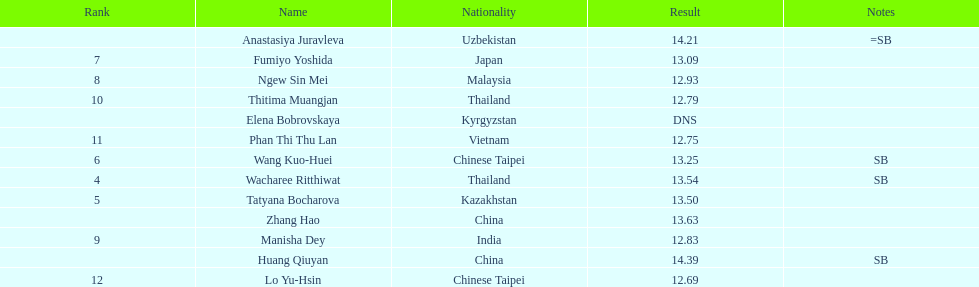Give me the full table as a dictionary. {'header': ['Rank', 'Name', 'Nationality', 'Result', 'Notes'], 'rows': [['', 'Anastasiya Juravleva', 'Uzbekistan', '14.21', '=SB'], ['7', 'Fumiyo Yoshida', 'Japan', '13.09', ''], ['8', 'Ngew Sin Mei', 'Malaysia', '12.93', ''], ['10', 'Thitima Muangjan', 'Thailand', '12.79', ''], ['', 'Elena Bobrovskaya', 'Kyrgyzstan', 'DNS', ''], ['11', 'Phan Thi Thu Lan', 'Vietnam', '12.75', ''], ['6', 'Wang Kuo-Huei', 'Chinese Taipei', '13.25', 'SB'], ['4', 'Wacharee Ritthiwat', 'Thailand', '13.54', 'SB'], ['5', 'Tatyana Bocharova', 'Kazakhstan', '13.50', ''], ['', 'Zhang Hao', 'China', '13.63', ''], ['9', 'Manisha Dey', 'India', '12.83', ''], ['', 'Huang Qiuyan', 'China', '14.39', 'SB'], ['12', 'Lo Yu-Hsin', 'Chinese Taipei', '12.69', '']]} What is the difference between huang qiuyan's result and fumiyo yoshida's result? 1.3. 